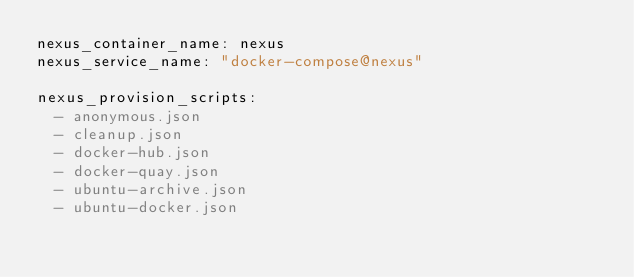<code> <loc_0><loc_0><loc_500><loc_500><_YAML_>nexus_container_name: nexus
nexus_service_name: "docker-compose@nexus"

nexus_provision_scripts:
  - anonymous.json
  - cleanup.json
  - docker-hub.json
  - docker-quay.json
  - ubuntu-archive.json
  - ubuntu-docker.json
</code> 